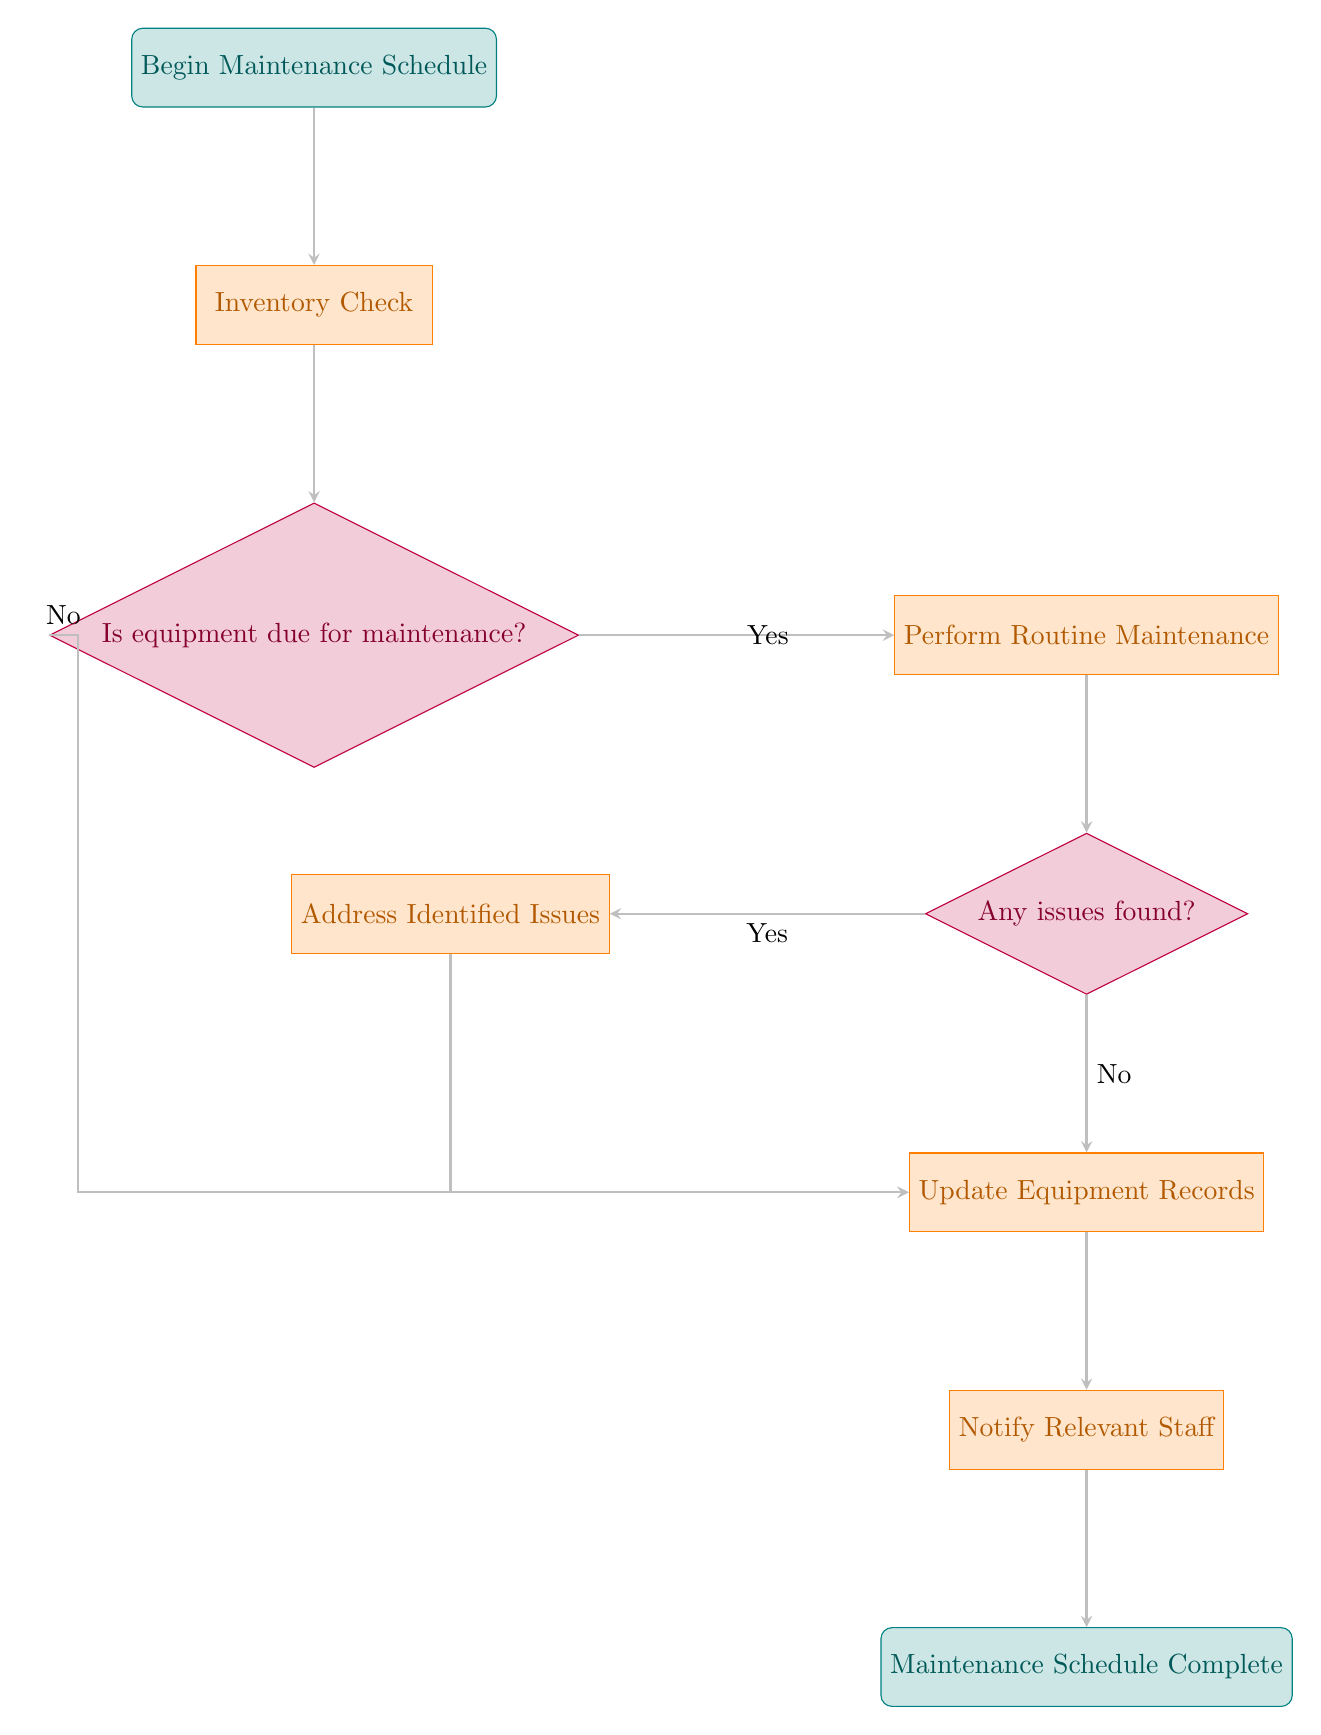What is the first step in the maintenance schedule? The first step in the flowchart is located at the top node labeled "Begin Maintenance Schedule". This indicates the starting point of the entire process.
Answer: Begin Maintenance Schedule How many processes are there in the diagram? A process node is indicated by a rectangular shape. After counting all the rectangle-shaped nodes, there are four processes: "Inventory Check", "Perform Routine Maintenance", "Update Equipment Records", and "Notify Relevant Staff".
Answer: 4 What action is taken if equipment is not due for maintenance? If the equipment is not due for maintenance, the flow indicates that it skips to the "Update Equipment Records" step. This flow moves horizontally to the left before connecting back down to the update node.
Answer: Update Equipment Records Which node follows the decision about whether issues are found? After the decision node labeled "Any issues found?", the next step depends on the outcome. If "Yes", it proceeds to the "Address Identified Issues" step; if "No", it proceeds directly to "Update Equipment Records". Since the prompt asks about the node that follows: if there are issues, the immediate step after is "Address Identified Issues".
Answer: Address Identified Issues What happens after updating equipment records? Following the "Update Equipment Records" process, the next step is to "Notify Relevant Staff". This is a direct downward flow from the update process that indicates a completion of record-keeping followed by a notification action.
Answer: Notify Relevant Staff What is the final outcome of the flowchart? At the very end of the flowchart, there’s a stop node labeled "Maintenance Schedule Complete". This indicates that all processes have been completed and the maintenance cycle is officially concluded.
Answer: Maintenance Schedule Complete What is the first process after inventory check? Immediately following the "Inventory Check" process, the next node is a decision labeled "Is equipment due for maintenance?". This flow directs the sequence towards evaluating whether the checking process necessitates further maintenance action.
Answer: Is equipment due for maintenance? 